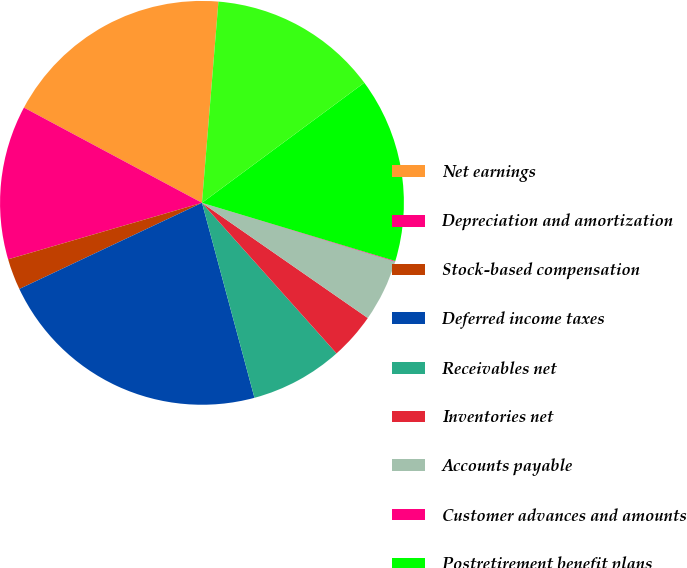Convert chart to OTSL. <chart><loc_0><loc_0><loc_500><loc_500><pie_chart><fcel>Net earnings<fcel>Depreciation and amortization<fcel>Stock-based compensation<fcel>Deferred income taxes<fcel>Receivables net<fcel>Inventories net<fcel>Accounts payable<fcel>Customer advances and amounts<fcel>Postretirement benefit plans<fcel>Income taxes<nl><fcel>18.48%<fcel>12.33%<fcel>2.5%<fcel>22.17%<fcel>7.42%<fcel>3.73%<fcel>4.96%<fcel>0.05%<fcel>14.79%<fcel>13.56%<nl></chart> 